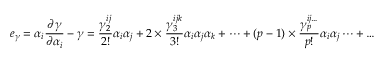<formula> <loc_0><loc_0><loc_500><loc_500>e _ { \gamma } = \alpha _ { i } \frac { \partial \gamma } { \partial \alpha _ { i } } - \gamma = \frac { \gamma _ { 2 } ^ { i j } } { 2 ! } \alpha _ { i } \alpha _ { j } + 2 \times \frac { \gamma _ { 3 } ^ { i j k } } { 3 ! } \alpha _ { i } \alpha _ { j } \alpha _ { k } + \dots + ( p - 1 ) \times \frac { \gamma _ { p } ^ { i j \dots } } { p ! } \alpha _ { i } \alpha _ { j } \dots + \dots</formula> 